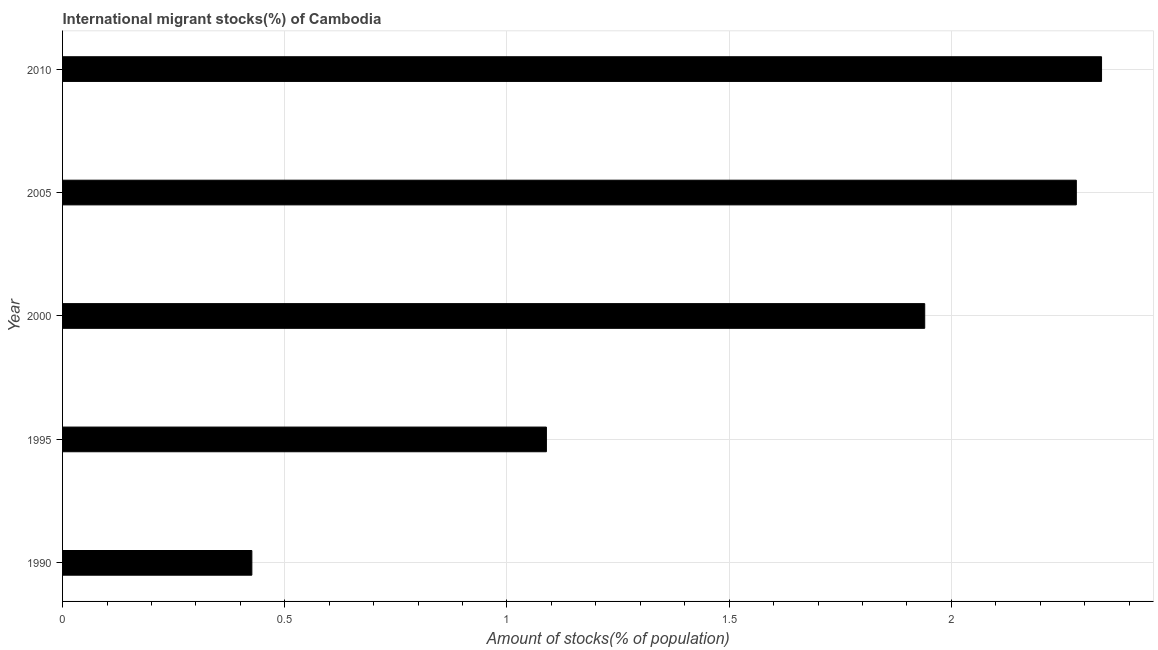Does the graph contain any zero values?
Your answer should be very brief. No. What is the title of the graph?
Give a very brief answer. International migrant stocks(%) of Cambodia. What is the label or title of the X-axis?
Provide a short and direct response. Amount of stocks(% of population). What is the label or title of the Y-axis?
Give a very brief answer. Year. What is the number of international migrant stocks in 2000?
Ensure brevity in your answer.  1.94. Across all years, what is the maximum number of international migrant stocks?
Your answer should be very brief. 2.34. Across all years, what is the minimum number of international migrant stocks?
Provide a succinct answer. 0.43. In which year was the number of international migrant stocks maximum?
Offer a very short reply. 2010. What is the sum of the number of international migrant stocks?
Provide a short and direct response. 8.07. What is the difference between the number of international migrant stocks in 1990 and 2000?
Your answer should be very brief. -1.51. What is the average number of international migrant stocks per year?
Provide a short and direct response. 1.61. What is the median number of international migrant stocks?
Ensure brevity in your answer.  1.94. In how many years, is the number of international migrant stocks greater than 2 %?
Offer a terse response. 2. What is the ratio of the number of international migrant stocks in 1995 to that in 2005?
Your answer should be very brief. 0.48. What is the difference between the highest and the second highest number of international migrant stocks?
Your response must be concise. 0.06. Is the sum of the number of international migrant stocks in 2000 and 2005 greater than the maximum number of international migrant stocks across all years?
Your answer should be compact. Yes. What is the difference between the highest and the lowest number of international migrant stocks?
Your response must be concise. 1.91. In how many years, is the number of international migrant stocks greater than the average number of international migrant stocks taken over all years?
Make the answer very short. 3. Are all the bars in the graph horizontal?
Provide a short and direct response. Yes. Are the values on the major ticks of X-axis written in scientific E-notation?
Provide a succinct answer. No. What is the Amount of stocks(% of population) in 1990?
Provide a succinct answer. 0.43. What is the Amount of stocks(% of population) of 1995?
Your answer should be compact. 1.09. What is the Amount of stocks(% of population) of 2000?
Give a very brief answer. 1.94. What is the Amount of stocks(% of population) of 2005?
Provide a short and direct response. 2.28. What is the Amount of stocks(% of population) in 2010?
Ensure brevity in your answer.  2.34. What is the difference between the Amount of stocks(% of population) in 1990 and 1995?
Keep it short and to the point. -0.66. What is the difference between the Amount of stocks(% of population) in 1990 and 2000?
Provide a succinct answer. -1.51. What is the difference between the Amount of stocks(% of population) in 1990 and 2005?
Give a very brief answer. -1.86. What is the difference between the Amount of stocks(% of population) in 1990 and 2010?
Your response must be concise. -1.91. What is the difference between the Amount of stocks(% of population) in 1995 and 2000?
Keep it short and to the point. -0.85. What is the difference between the Amount of stocks(% of population) in 1995 and 2005?
Your answer should be compact. -1.19. What is the difference between the Amount of stocks(% of population) in 1995 and 2010?
Keep it short and to the point. -1.25. What is the difference between the Amount of stocks(% of population) in 2000 and 2005?
Offer a terse response. -0.34. What is the difference between the Amount of stocks(% of population) in 2000 and 2010?
Your answer should be very brief. -0.4. What is the difference between the Amount of stocks(% of population) in 2005 and 2010?
Your response must be concise. -0.06. What is the ratio of the Amount of stocks(% of population) in 1990 to that in 1995?
Provide a short and direct response. 0.39. What is the ratio of the Amount of stocks(% of population) in 1990 to that in 2000?
Provide a succinct answer. 0.22. What is the ratio of the Amount of stocks(% of population) in 1990 to that in 2005?
Your answer should be very brief. 0.19. What is the ratio of the Amount of stocks(% of population) in 1990 to that in 2010?
Provide a short and direct response. 0.18. What is the ratio of the Amount of stocks(% of population) in 1995 to that in 2000?
Provide a short and direct response. 0.56. What is the ratio of the Amount of stocks(% of population) in 1995 to that in 2005?
Your response must be concise. 0.48. What is the ratio of the Amount of stocks(% of population) in 1995 to that in 2010?
Offer a terse response. 0.47. What is the ratio of the Amount of stocks(% of population) in 2000 to that in 2005?
Provide a short and direct response. 0.85. What is the ratio of the Amount of stocks(% of population) in 2000 to that in 2010?
Offer a very short reply. 0.83. What is the ratio of the Amount of stocks(% of population) in 2005 to that in 2010?
Keep it short and to the point. 0.98. 